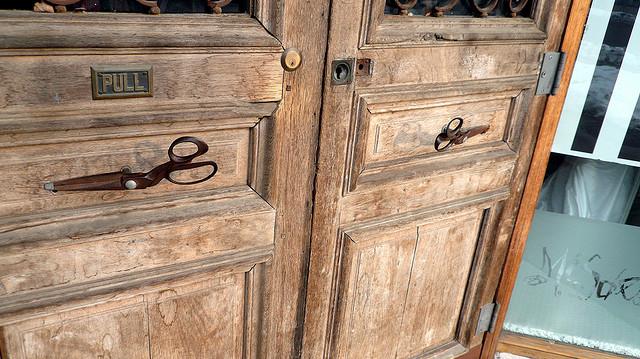Do you push to open the door?
Short answer required. No. What do the door handles resemble?
Quick response, please. Scissors. What method is used to open the door?
Be succinct. Pull. 